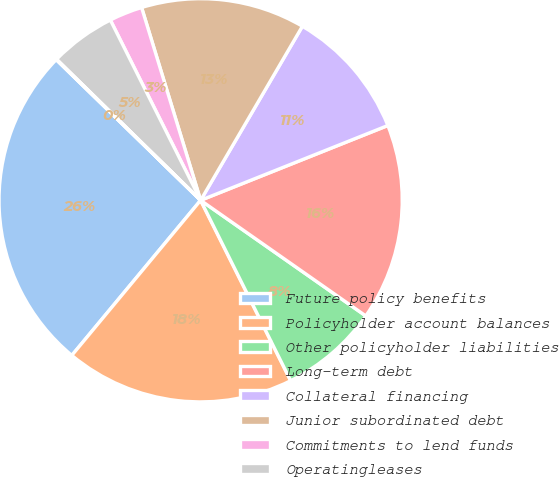Convert chart. <chart><loc_0><loc_0><loc_500><loc_500><pie_chart><fcel>Future policy benefits<fcel>Policyholder account balances<fcel>Other policyholder liabilities<fcel>Long-term debt<fcel>Collateral financing<fcel>Junior subordinated debt<fcel>Commitments to lend funds<fcel>Operatingleases<fcel>Other<nl><fcel>26.26%<fcel>18.4%<fcel>7.91%<fcel>15.77%<fcel>10.53%<fcel>13.15%<fcel>2.66%<fcel>5.28%<fcel>0.04%<nl></chart> 